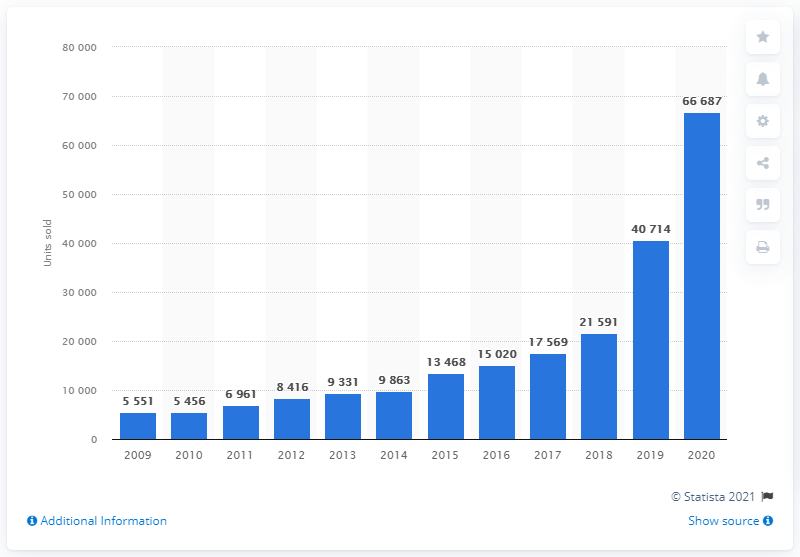Mention a couple of crucial points in this snapshot. In 2019, a total of 4,071 alternative fuel cars were sold in Switzerland. 